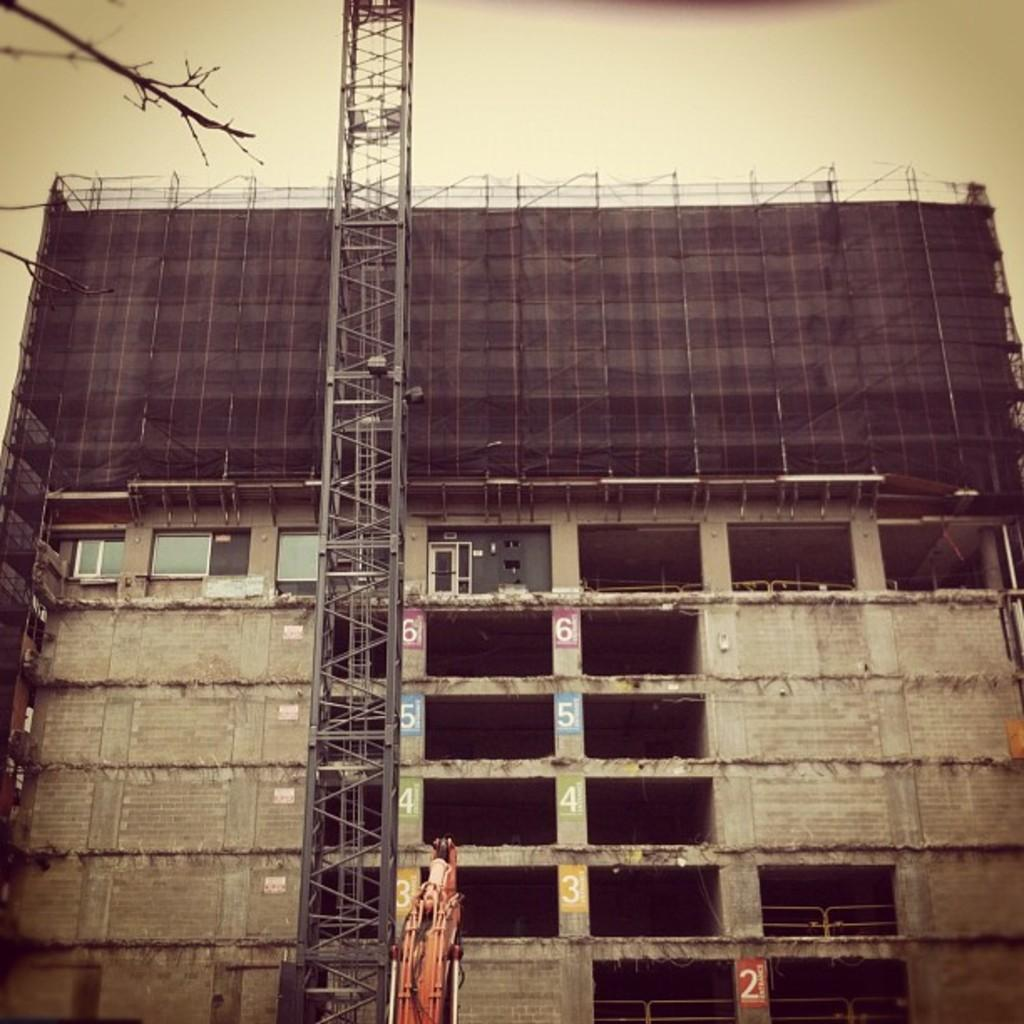What type of structure is being built in the image? There is a building under construction in the image. What other prominent feature can be seen in the image? There is a tower in the image. What type of vegetation is visible in the image? Tree stems are visible in the image. What is visible in the background of the image? The sky is visible in the image. Where is your aunt standing with the babies in the image? There is no aunt or babies present in the image; it features a building under construction, a tower, tree stems, and the sky. What type of seed can be seen growing near the tree stems in the image? There is no seed visible in the image; only tree stems are mentioned. 